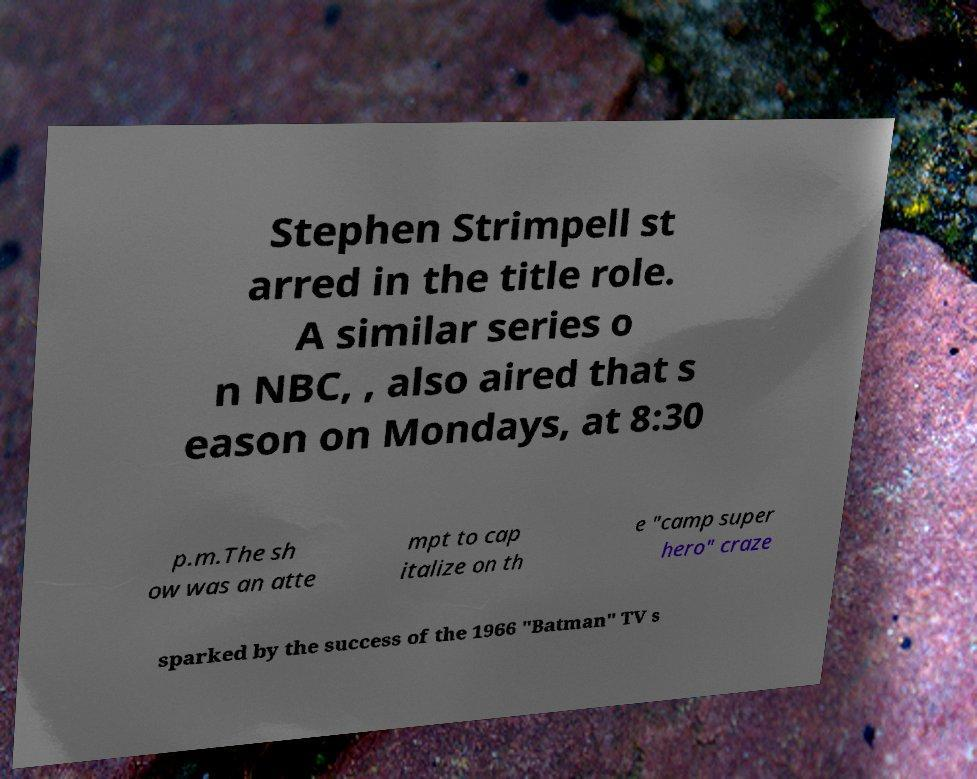For documentation purposes, I need the text within this image transcribed. Could you provide that? Stephen Strimpell st arred in the title role. A similar series o n NBC, , also aired that s eason on Mondays, at 8:30 p.m.The sh ow was an atte mpt to cap italize on th e "camp super hero" craze sparked by the success of the 1966 "Batman" TV s 